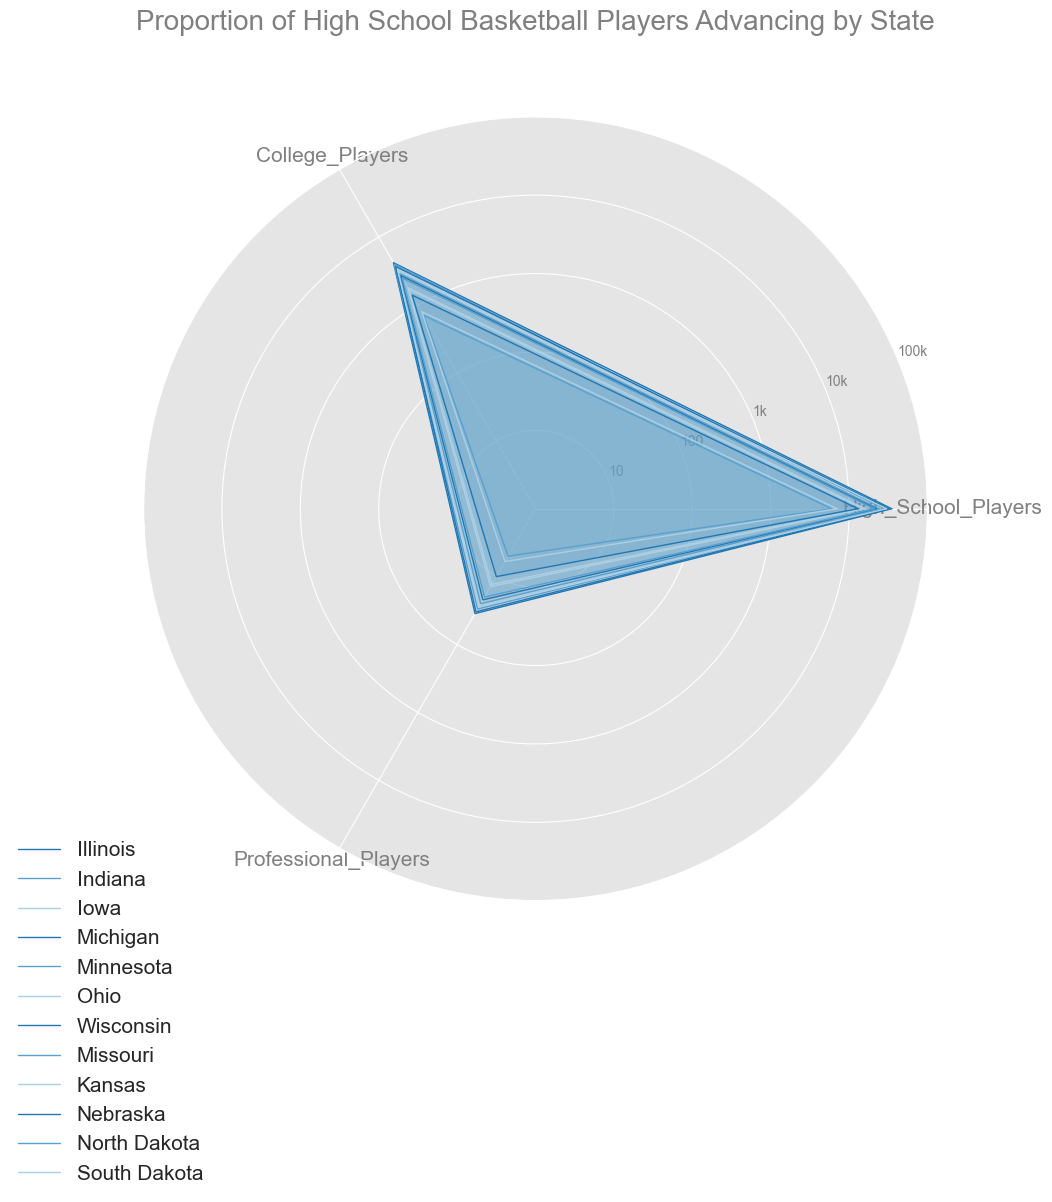Which state has the highest number of high school basketball players? Illinois has the highest number of high school basketball players. This can be observed by identifying the line that extends furthest along the "High School Players" axis.
Answer: Illinois Which state has the fewest number of professional basketball players? North Dakota has the fewest number of professional basketball players. This is evident from the shortest line on the "Professional Players" axis.
Answer: North Dakota How many more college players does Illinois have compared to Michigan? Illinois has 4200 college players, while Michigan has 3700. Subtracting Michigan's count from Illinois' gives 4200 - 3700 = 500. Therefore, Illinois has 500 more college players compared to Michigan.
Answer: 500 If you add the number of professional players from Indiana, Iowa, and Wisconsin, how many do you get? Indiana has 30 professional players, Iowa has 13, and Wisconsin has 22. Adding these up: 30 + 13 + 22 = 65. So, the total number of professional players from these states is 65.
Answer: 65 Which state has a higher proportion of college players to high school players, Nebraska or South Dakota? Nebraska has 13000 high school players and 1400 college players, resulting in a proportion of 1400 / 13000 = 0.1077. South Dakota has 7000 high school players and 800 college players, resulting in a proportion of 800 / 7000 = 0.1143. Therefore, South Dakota has a higher proportion.
Answer: South Dakota Compare the number of high school players in Ohio to Minnesota. By what factor is Ohio's number larger or smaller than Minnesota's? Ohio has 30000 high school players, and Minnesota has 24000. The factor by which Ohio's number is larger is 30000 / 24000 = 1.25. So, Ohio has 1.25 times more high school players compared to Minnesota.
Answer: 1.25 times Which state shows the smallest drop from high school to professional players? This can be determined by comparing the line lengths from "High School Players" to "Professional Players". Illinois shows the smallest relative drop as its line lengths are closer between these two categories.
Answer: Illinois Between Kansas and Iowa, which state has a greater absolute difference between college and professional players? Kansas has 1800 college players and 14 professional players, resulting in a difference of 1800 - 14 = 1786. Iowa has 1700 college players and 13 professional players, resulting in a difference of 1700 - 13 = 1687. So, Kansas has a greater absolute difference.
Answer: Kansas Which state has the lowest ratio of professional players to college players? North Dakota has 700 college players and 5 professional players, resulting in a ratio of 5 / 700 = 0.0071. This is the lowest ratio when compared visually.
Answer: North Dakota Is the number of high school players in Missouri greater than or equal to the number of college players in Illinois? Missouri has 21000 high school players, and Illinois has 4200 college players. Since 21000 is greater than 4200, the number of high school players in Missouri is indeed greater than the number of college players in Illinois.
Answer: Yes 